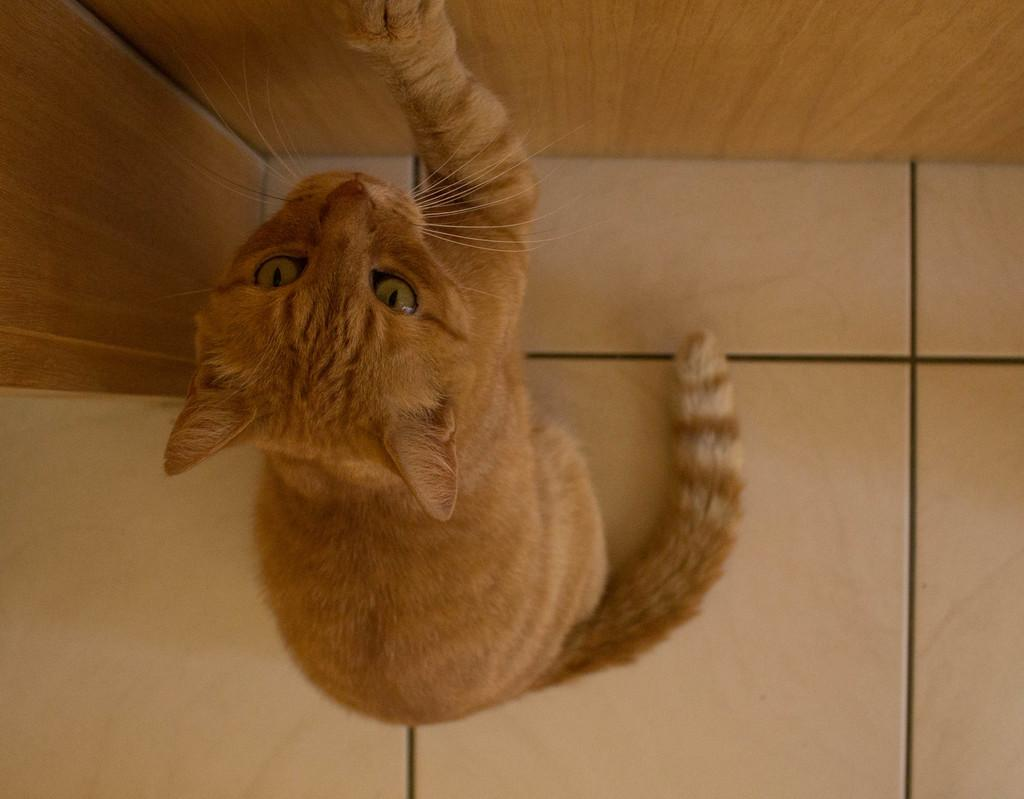What type of animal is in the image? There is a cat in the image. Where is the cat located in the image? The cat is on the floor. What is the chance of the cat winning a race in the image? There is no race present in the image, so it is not possible to determine the cat's chances of winning. 